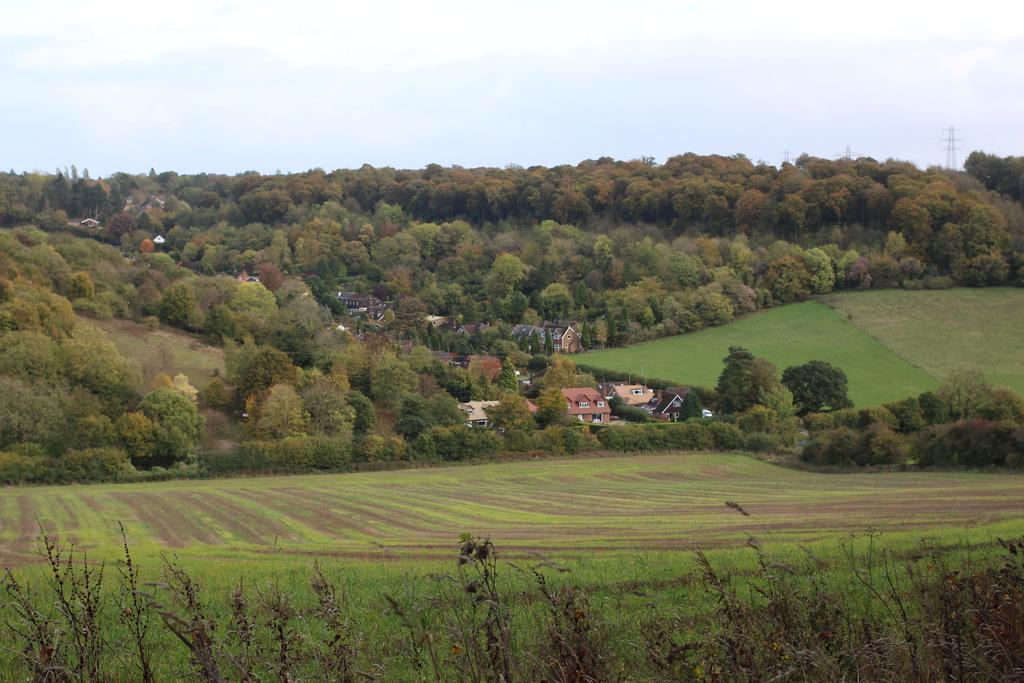What type of surface is visible at the bottom of the image? There is grass on the surface at the bottom of the image. What can be seen in the background of the image? There are buildings, trees, and towers in the background of the image. What part of the natural environment is visible in the image? The sky is visible in the background of the image. How many bikes are parked on the grass in the image? There are no bikes present in the image; it only features grass, buildings, trees, towers, and the sky. What type of calculations can be performed using the calculator in the image? There is no calculator present in the image. 